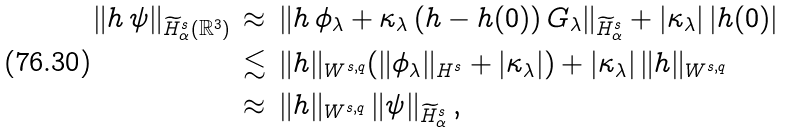<formula> <loc_0><loc_0><loc_500><loc_500>\| h \, \psi \| _ { \widetilde { H } ^ { s } _ { \alpha } ( \mathbb { R } ^ { 3 } ) } \, & \approx \, \| h \, \phi _ { \lambda } + \kappa _ { \lambda } \, ( h - h ( 0 ) ) \, G _ { \lambda } \| _ { \widetilde { H } ^ { s } _ { \alpha } } + | \kappa _ { \lambda } | \, | h ( 0 ) | \\ & \lesssim \, \| h \| _ { W ^ { s , q } } ( \| \phi _ { \lambda } \| _ { H ^ { s } } + | \kappa _ { \lambda } | ) + | \kappa _ { \lambda } | \, \| h \| _ { W ^ { s , q } } \\ & \approx \, \| h \| _ { W ^ { s , q } } \, \| \psi \| _ { \widetilde { H } ^ { s } _ { \alpha } } \, ,</formula> 